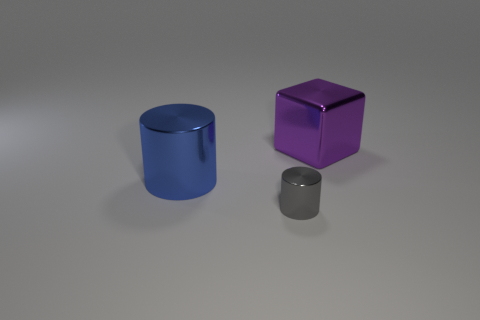Are there an equal number of tiny cylinders that are behind the purple metal cube and cylinders to the left of the big blue object?
Your response must be concise. Yes. Do the shiny cylinder that is behind the small gray metallic thing and the object that is right of the tiny metallic thing have the same color?
Your response must be concise. No. Are there more large metallic objects that are behind the big purple metal cube than gray cylinders?
Your response must be concise. No. The small object that is made of the same material as the block is what shape?
Your answer should be compact. Cylinder. There is a thing left of the gray shiny thing; does it have the same size as the metallic block?
Your response must be concise. Yes. There is a metallic object in front of the big thing that is left of the tiny gray metallic cylinder; what shape is it?
Offer a terse response. Cylinder. How big is the object that is in front of the big object on the left side of the small gray cylinder?
Provide a succinct answer. Small. What is the color of the large metal thing that is in front of the purple thing?
Make the answer very short. Blue. There is a cylinder that is the same material as the small gray object; what size is it?
Ensure brevity in your answer.  Large. What number of other big purple metallic things have the same shape as the large purple object?
Offer a terse response. 0. 